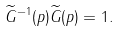Convert formula to latex. <formula><loc_0><loc_0><loc_500><loc_500>\widetilde { G } ^ { - 1 } ( p ) \widetilde { G } ( p ) = 1 .</formula> 